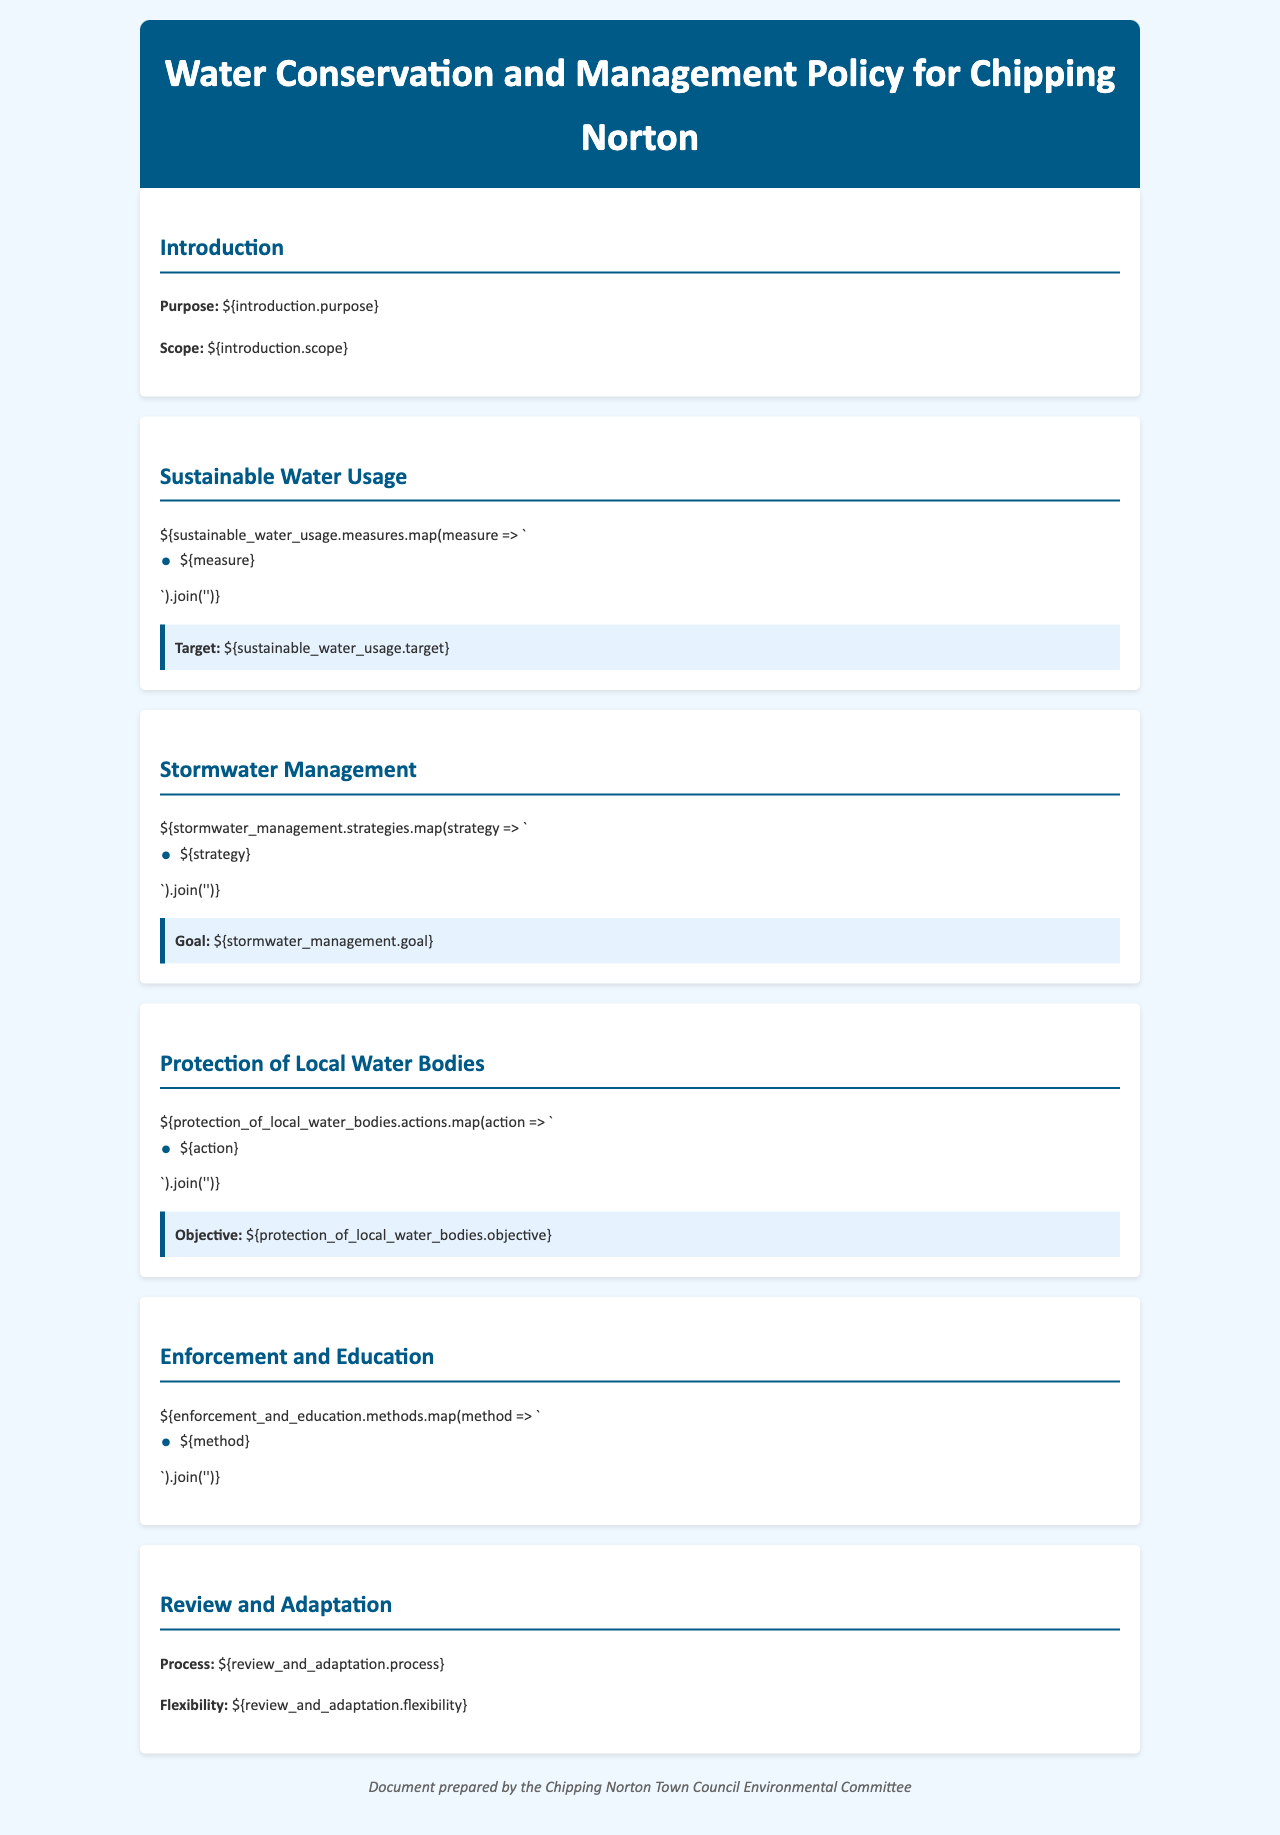What is the purpose of the policy? The purpose is defined in the Introduction section of the document.
Answer: Purpose of the policy What strategies are included in the Stormwater Management section? Strategies are listed as bullet points in the Stormwater Management section.
Answer: [list of strategies] What is the target for sustainable water usage? The target is specified in the Sustainable Water Usage section after the measures.
Answer: [specific target] What is the objective for the protection of local water bodies? The objective is articulated in the Protection of Local Water Bodies section.
Answer: [specific objective] What is the process for review and adaptation? The process is described in the Review and Adaptation section.
Answer: [specific process] Which committee prepared the document? The committee responsible for the document is mentioned in the footer.
Answer: Chipping Norton Town Council Environmental Committee What methods are mentioned under Enforcement and Education? Methods are detailed as bullet points in the Enforcement and Education section.
Answer: [list of methods] What is the goal of the stormwater management program? The goal is highlighted in the Stormwater Management section.
Answer: [specific goal] What aspect of water management does the policy address? The policy addresses several aspects, such as sustainable usage, stormwater management, and water body protection.
Answer: Sustainable water usage, stormwater management, protection of local water bodies 